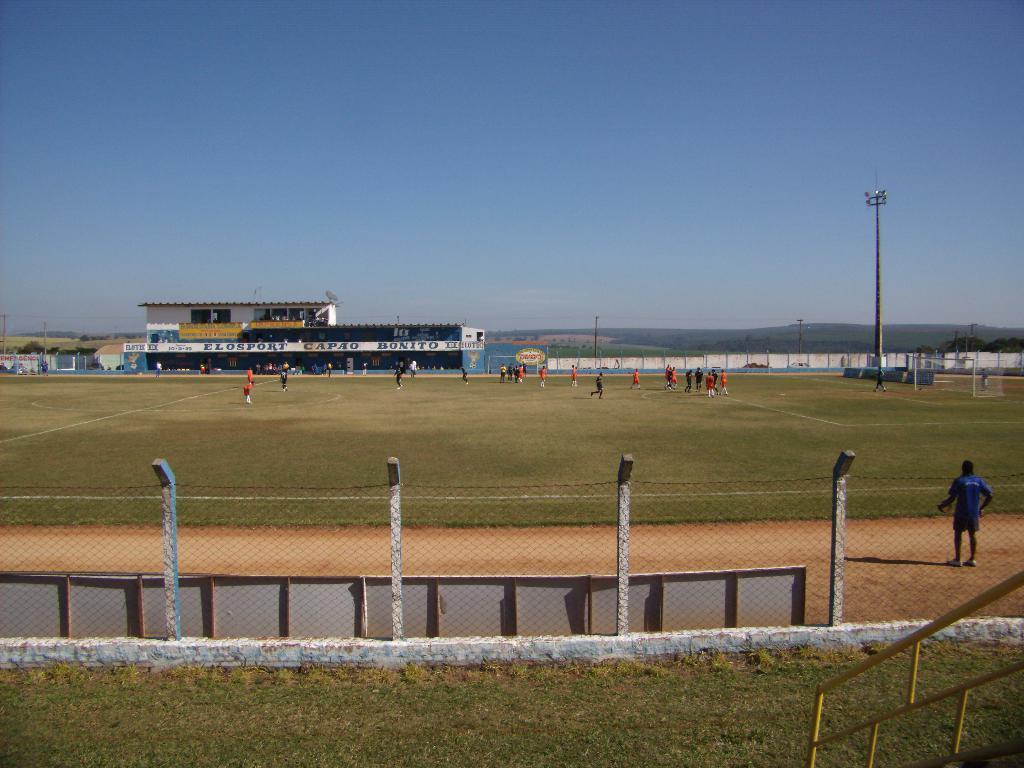Please provide a concise description of this image. This picture is clicked outside. In the foreground we can see the green grass and the net and some other objects and there is a person standing on the ground. In the center we can see the group of people and the green grass. In the background there is a ski, pole and sheds and some trees. 